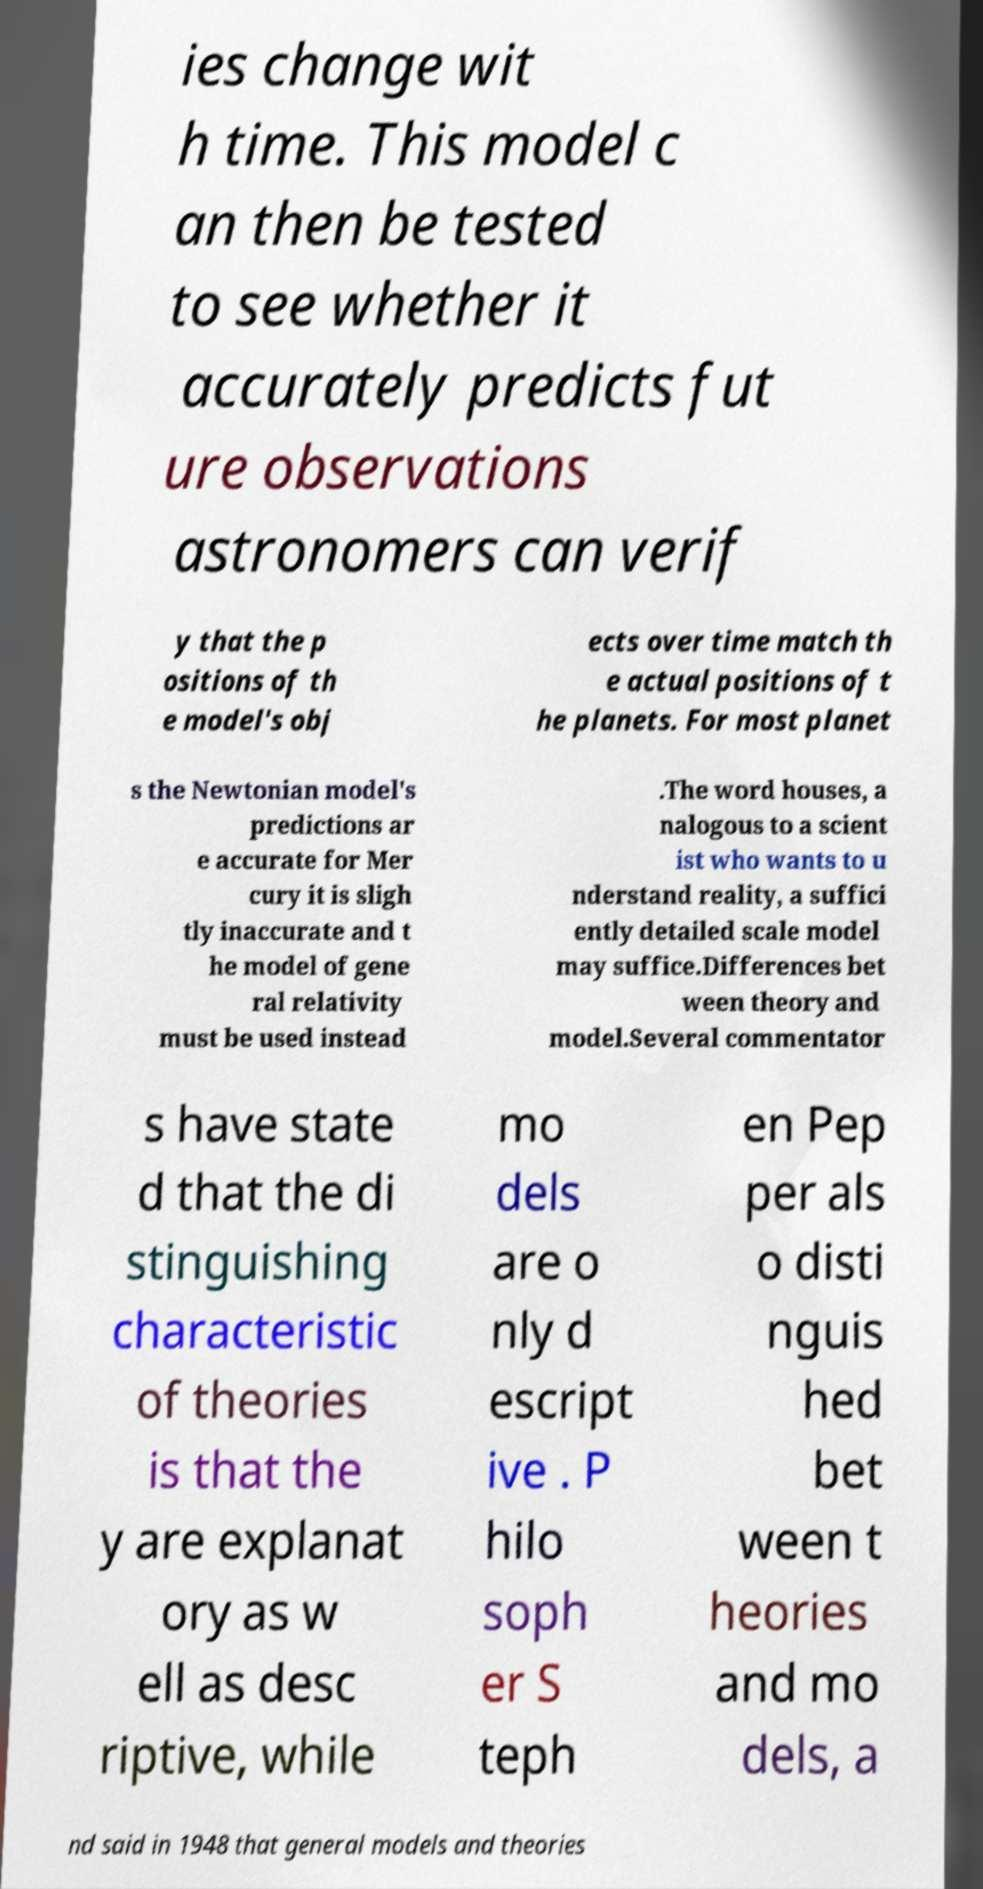I need the written content from this picture converted into text. Can you do that? ies change wit h time. This model c an then be tested to see whether it accurately predicts fut ure observations astronomers can verif y that the p ositions of th e model's obj ects over time match th e actual positions of t he planets. For most planet s the Newtonian model's predictions ar e accurate for Mer cury it is sligh tly inaccurate and t he model of gene ral relativity must be used instead .The word houses, a nalogous to a scient ist who wants to u nderstand reality, a suffici ently detailed scale model may suffice.Differences bet ween theory and model.Several commentator s have state d that the di stinguishing characteristic of theories is that the y are explanat ory as w ell as desc riptive, while mo dels are o nly d escript ive . P hilo soph er S teph en Pep per als o disti nguis hed bet ween t heories and mo dels, a nd said in 1948 that general models and theories 